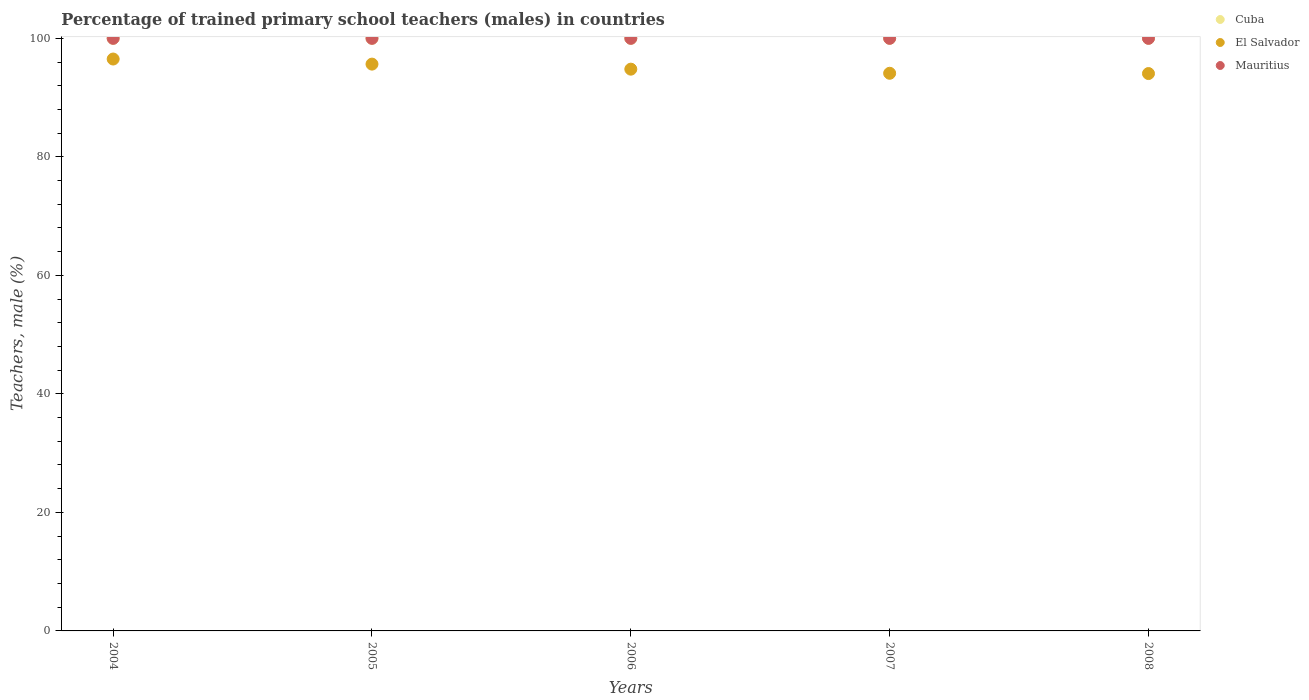How many different coloured dotlines are there?
Ensure brevity in your answer.  3. What is the percentage of trained primary school teachers (males) in El Salvador in 2006?
Ensure brevity in your answer.  94.8. Across all years, what is the maximum percentage of trained primary school teachers (males) in Mauritius?
Provide a succinct answer. 100. In which year was the percentage of trained primary school teachers (males) in Mauritius maximum?
Keep it short and to the point. 2004. In which year was the percentage of trained primary school teachers (males) in El Salvador minimum?
Your response must be concise. 2008. What is the total percentage of trained primary school teachers (males) in El Salvador in the graph?
Your answer should be very brief. 475.12. What is the difference between the percentage of trained primary school teachers (males) in Cuba in 2006 and the percentage of trained primary school teachers (males) in Mauritius in 2008?
Give a very brief answer. 0. In how many years, is the percentage of trained primary school teachers (males) in Cuba greater than 84 %?
Your answer should be compact. 5. What is the ratio of the percentage of trained primary school teachers (males) in El Salvador in 2006 to that in 2007?
Offer a terse response. 1.01. Is the percentage of trained primary school teachers (males) in Cuba in 2006 less than that in 2008?
Give a very brief answer. No. What is the difference between the highest and the second highest percentage of trained primary school teachers (males) in El Salvador?
Keep it short and to the point. 0.86. Is the sum of the percentage of trained primary school teachers (males) in Mauritius in 2005 and 2008 greater than the maximum percentage of trained primary school teachers (males) in Cuba across all years?
Provide a succinct answer. Yes. Is it the case that in every year, the sum of the percentage of trained primary school teachers (males) in Mauritius and percentage of trained primary school teachers (males) in El Salvador  is greater than the percentage of trained primary school teachers (males) in Cuba?
Ensure brevity in your answer.  Yes. Does the percentage of trained primary school teachers (males) in Cuba monotonically increase over the years?
Your answer should be compact. No. Is the percentage of trained primary school teachers (males) in Cuba strictly greater than the percentage of trained primary school teachers (males) in El Salvador over the years?
Make the answer very short. Yes. How many dotlines are there?
Provide a succinct answer. 3. How many years are there in the graph?
Keep it short and to the point. 5. Are the values on the major ticks of Y-axis written in scientific E-notation?
Ensure brevity in your answer.  No. Does the graph contain any zero values?
Make the answer very short. No. Does the graph contain grids?
Ensure brevity in your answer.  No. Where does the legend appear in the graph?
Provide a short and direct response. Top right. How are the legend labels stacked?
Make the answer very short. Vertical. What is the title of the graph?
Ensure brevity in your answer.  Percentage of trained primary school teachers (males) in countries. What is the label or title of the Y-axis?
Provide a succinct answer. Teachers, male (%). What is the Teachers, male (%) of Cuba in 2004?
Your answer should be compact. 100. What is the Teachers, male (%) of El Salvador in 2004?
Provide a short and direct response. 96.51. What is the Teachers, male (%) of Mauritius in 2004?
Your response must be concise. 100. What is the Teachers, male (%) of Cuba in 2005?
Your answer should be very brief. 100. What is the Teachers, male (%) of El Salvador in 2005?
Keep it short and to the point. 95.65. What is the Teachers, male (%) of Cuba in 2006?
Your answer should be very brief. 100. What is the Teachers, male (%) of El Salvador in 2006?
Offer a very short reply. 94.8. What is the Teachers, male (%) of Mauritius in 2006?
Offer a very short reply. 100. What is the Teachers, male (%) in Cuba in 2007?
Your answer should be very brief. 100. What is the Teachers, male (%) of El Salvador in 2007?
Your answer should be compact. 94.1. What is the Teachers, male (%) of Mauritius in 2007?
Provide a short and direct response. 100. What is the Teachers, male (%) in El Salvador in 2008?
Provide a succinct answer. 94.06. Across all years, what is the maximum Teachers, male (%) of Cuba?
Provide a short and direct response. 100. Across all years, what is the maximum Teachers, male (%) in El Salvador?
Ensure brevity in your answer.  96.51. Across all years, what is the maximum Teachers, male (%) in Mauritius?
Your answer should be very brief. 100. Across all years, what is the minimum Teachers, male (%) of Cuba?
Keep it short and to the point. 100. Across all years, what is the minimum Teachers, male (%) in El Salvador?
Provide a short and direct response. 94.06. Across all years, what is the minimum Teachers, male (%) in Mauritius?
Offer a very short reply. 100. What is the total Teachers, male (%) of Cuba in the graph?
Your answer should be very brief. 500. What is the total Teachers, male (%) of El Salvador in the graph?
Keep it short and to the point. 475.12. What is the difference between the Teachers, male (%) in El Salvador in 2004 and that in 2005?
Ensure brevity in your answer.  0.86. What is the difference between the Teachers, male (%) in Mauritius in 2004 and that in 2005?
Offer a very short reply. 0. What is the difference between the Teachers, male (%) in El Salvador in 2004 and that in 2006?
Offer a terse response. 1.71. What is the difference between the Teachers, male (%) of Mauritius in 2004 and that in 2006?
Offer a terse response. 0. What is the difference between the Teachers, male (%) of El Salvador in 2004 and that in 2007?
Offer a very short reply. 2.4. What is the difference between the Teachers, male (%) of Mauritius in 2004 and that in 2007?
Your answer should be compact. 0. What is the difference between the Teachers, male (%) in El Salvador in 2004 and that in 2008?
Ensure brevity in your answer.  2.45. What is the difference between the Teachers, male (%) of Mauritius in 2004 and that in 2008?
Offer a terse response. 0. What is the difference between the Teachers, male (%) of El Salvador in 2005 and that in 2006?
Give a very brief answer. 0.85. What is the difference between the Teachers, male (%) of Cuba in 2005 and that in 2007?
Provide a short and direct response. 0. What is the difference between the Teachers, male (%) of El Salvador in 2005 and that in 2007?
Your response must be concise. 1.55. What is the difference between the Teachers, male (%) in Mauritius in 2005 and that in 2007?
Keep it short and to the point. 0. What is the difference between the Teachers, male (%) in El Salvador in 2005 and that in 2008?
Offer a terse response. 1.59. What is the difference between the Teachers, male (%) in Cuba in 2006 and that in 2007?
Ensure brevity in your answer.  0. What is the difference between the Teachers, male (%) in El Salvador in 2006 and that in 2007?
Provide a succinct answer. 0.69. What is the difference between the Teachers, male (%) in Mauritius in 2006 and that in 2007?
Offer a terse response. 0. What is the difference between the Teachers, male (%) of El Salvador in 2006 and that in 2008?
Give a very brief answer. 0.74. What is the difference between the Teachers, male (%) of Mauritius in 2006 and that in 2008?
Offer a terse response. 0. What is the difference between the Teachers, male (%) in Cuba in 2007 and that in 2008?
Your answer should be compact. 0. What is the difference between the Teachers, male (%) in El Salvador in 2007 and that in 2008?
Your answer should be very brief. 0.05. What is the difference between the Teachers, male (%) in Cuba in 2004 and the Teachers, male (%) in El Salvador in 2005?
Make the answer very short. 4.35. What is the difference between the Teachers, male (%) in El Salvador in 2004 and the Teachers, male (%) in Mauritius in 2005?
Provide a succinct answer. -3.49. What is the difference between the Teachers, male (%) of Cuba in 2004 and the Teachers, male (%) of El Salvador in 2006?
Your answer should be compact. 5.2. What is the difference between the Teachers, male (%) in El Salvador in 2004 and the Teachers, male (%) in Mauritius in 2006?
Provide a short and direct response. -3.49. What is the difference between the Teachers, male (%) of Cuba in 2004 and the Teachers, male (%) of El Salvador in 2007?
Offer a very short reply. 5.9. What is the difference between the Teachers, male (%) of Cuba in 2004 and the Teachers, male (%) of Mauritius in 2007?
Give a very brief answer. 0. What is the difference between the Teachers, male (%) of El Salvador in 2004 and the Teachers, male (%) of Mauritius in 2007?
Provide a short and direct response. -3.49. What is the difference between the Teachers, male (%) in Cuba in 2004 and the Teachers, male (%) in El Salvador in 2008?
Keep it short and to the point. 5.94. What is the difference between the Teachers, male (%) in Cuba in 2004 and the Teachers, male (%) in Mauritius in 2008?
Provide a short and direct response. 0. What is the difference between the Teachers, male (%) in El Salvador in 2004 and the Teachers, male (%) in Mauritius in 2008?
Your answer should be very brief. -3.49. What is the difference between the Teachers, male (%) in Cuba in 2005 and the Teachers, male (%) in El Salvador in 2006?
Provide a short and direct response. 5.2. What is the difference between the Teachers, male (%) in El Salvador in 2005 and the Teachers, male (%) in Mauritius in 2006?
Provide a short and direct response. -4.35. What is the difference between the Teachers, male (%) of Cuba in 2005 and the Teachers, male (%) of El Salvador in 2007?
Ensure brevity in your answer.  5.9. What is the difference between the Teachers, male (%) in Cuba in 2005 and the Teachers, male (%) in Mauritius in 2007?
Your answer should be very brief. 0. What is the difference between the Teachers, male (%) in El Salvador in 2005 and the Teachers, male (%) in Mauritius in 2007?
Offer a terse response. -4.35. What is the difference between the Teachers, male (%) in Cuba in 2005 and the Teachers, male (%) in El Salvador in 2008?
Your response must be concise. 5.94. What is the difference between the Teachers, male (%) of Cuba in 2005 and the Teachers, male (%) of Mauritius in 2008?
Make the answer very short. 0. What is the difference between the Teachers, male (%) of El Salvador in 2005 and the Teachers, male (%) of Mauritius in 2008?
Give a very brief answer. -4.35. What is the difference between the Teachers, male (%) in Cuba in 2006 and the Teachers, male (%) in El Salvador in 2007?
Offer a very short reply. 5.9. What is the difference between the Teachers, male (%) of Cuba in 2006 and the Teachers, male (%) of Mauritius in 2007?
Keep it short and to the point. 0. What is the difference between the Teachers, male (%) of El Salvador in 2006 and the Teachers, male (%) of Mauritius in 2007?
Give a very brief answer. -5.2. What is the difference between the Teachers, male (%) of Cuba in 2006 and the Teachers, male (%) of El Salvador in 2008?
Provide a short and direct response. 5.94. What is the difference between the Teachers, male (%) in Cuba in 2006 and the Teachers, male (%) in Mauritius in 2008?
Ensure brevity in your answer.  0. What is the difference between the Teachers, male (%) in El Salvador in 2006 and the Teachers, male (%) in Mauritius in 2008?
Offer a terse response. -5.2. What is the difference between the Teachers, male (%) of Cuba in 2007 and the Teachers, male (%) of El Salvador in 2008?
Provide a succinct answer. 5.94. What is the difference between the Teachers, male (%) of El Salvador in 2007 and the Teachers, male (%) of Mauritius in 2008?
Keep it short and to the point. -5.9. What is the average Teachers, male (%) in Cuba per year?
Your answer should be compact. 100. What is the average Teachers, male (%) in El Salvador per year?
Provide a short and direct response. 95.02. In the year 2004, what is the difference between the Teachers, male (%) of Cuba and Teachers, male (%) of El Salvador?
Your answer should be very brief. 3.49. In the year 2004, what is the difference between the Teachers, male (%) in El Salvador and Teachers, male (%) in Mauritius?
Your answer should be very brief. -3.49. In the year 2005, what is the difference between the Teachers, male (%) of Cuba and Teachers, male (%) of El Salvador?
Provide a short and direct response. 4.35. In the year 2005, what is the difference between the Teachers, male (%) in El Salvador and Teachers, male (%) in Mauritius?
Offer a terse response. -4.35. In the year 2006, what is the difference between the Teachers, male (%) in Cuba and Teachers, male (%) in El Salvador?
Provide a succinct answer. 5.2. In the year 2006, what is the difference between the Teachers, male (%) of Cuba and Teachers, male (%) of Mauritius?
Make the answer very short. 0. In the year 2006, what is the difference between the Teachers, male (%) in El Salvador and Teachers, male (%) in Mauritius?
Keep it short and to the point. -5.2. In the year 2007, what is the difference between the Teachers, male (%) in Cuba and Teachers, male (%) in El Salvador?
Offer a terse response. 5.9. In the year 2007, what is the difference between the Teachers, male (%) of Cuba and Teachers, male (%) of Mauritius?
Offer a very short reply. 0. In the year 2007, what is the difference between the Teachers, male (%) of El Salvador and Teachers, male (%) of Mauritius?
Keep it short and to the point. -5.9. In the year 2008, what is the difference between the Teachers, male (%) of Cuba and Teachers, male (%) of El Salvador?
Ensure brevity in your answer.  5.94. In the year 2008, what is the difference between the Teachers, male (%) of Cuba and Teachers, male (%) of Mauritius?
Offer a terse response. 0. In the year 2008, what is the difference between the Teachers, male (%) of El Salvador and Teachers, male (%) of Mauritius?
Offer a very short reply. -5.94. What is the ratio of the Teachers, male (%) in Mauritius in 2004 to that in 2005?
Ensure brevity in your answer.  1. What is the ratio of the Teachers, male (%) of Cuba in 2004 to that in 2006?
Give a very brief answer. 1. What is the ratio of the Teachers, male (%) of El Salvador in 2004 to that in 2006?
Offer a terse response. 1.02. What is the ratio of the Teachers, male (%) of Mauritius in 2004 to that in 2006?
Provide a short and direct response. 1. What is the ratio of the Teachers, male (%) in Cuba in 2004 to that in 2007?
Provide a succinct answer. 1. What is the ratio of the Teachers, male (%) in El Salvador in 2004 to that in 2007?
Provide a short and direct response. 1.03. What is the ratio of the Teachers, male (%) of Cuba in 2005 to that in 2006?
Your answer should be very brief. 1. What is the ratio of the Teachers, male (%) of El Salvador in 2005 to that in 2006?
Your answer should be compact. 1.01. What is the ratio of the Teachers, male (%) in El Salvador in 2005 to that in 2007?
Keep it short and to the point. 1.02. What is the ratio of the Teachers, male (%) in El Salvador in 2005 to that in 2008?
Make the answer very short. 1.02. What is the ratio of the Teachers, male (%) in El Salvador in 2006 to that in 2007?
Provide a short and direct response. 1.01. What is the ratio of the Teachers, male (%) of Mauritius in 2006 to that in 2007?
Ensure brevity in your answer.  1. What is the ratio of the Teachers, male (%) of El Salvador in 2006 to that in 2008?
Offer a terse response. 1.01. What is the ratio of the Teachers, male (%) in Cuba in 2007 to that in 2008?
Provide a succinct answer. 1. What is the ratio of the Teachers, male (%) in Mauritius in 2007 to that in 2008?
Your response must be concise. 1. What is the difference between the highest and the second highest Teachers, male (%) of El Salvador?
Your response must be concise. 0.86. What is the difference between the highest and the second highest Teachers, male (%) of Mauritius?
Your answer should be very brief. 0. What is the difference between the highest and the lowest Teachers, male (%) of El Salvador?
Offer a terse response. 2.45. What is the difference between the highest and the lowest Teachers, male (%) of Mauritius?
Offer a terse response. 0. 